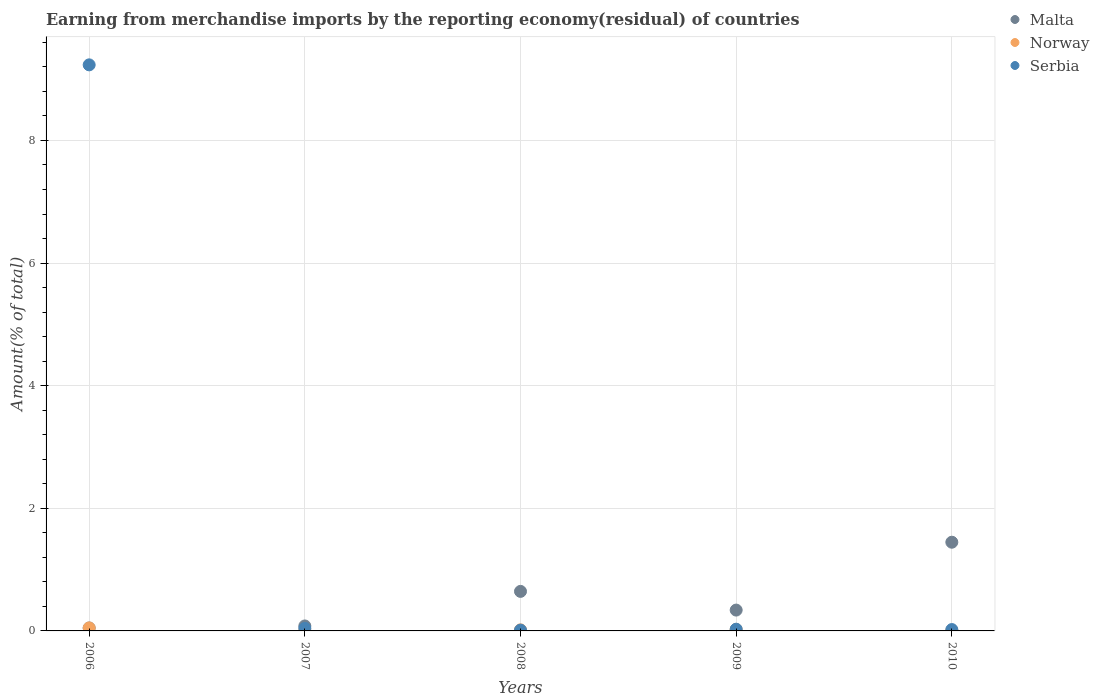Is the number of dotlines equal to the number of legend labels?
Your answer should be very brief. Yes. What is the percentage of amount earned from merchandise imports in Serbia in 2007?
Offer a very short reply. 0.04. Across all years, what is the maximum percentage of amount earned from merchandise imports in Malta?
Offer a very short reply. 1.45. Across all years, what is the minimum percentage of amount earned from merchandise imports in Norway?
Offer a terse response. 0.01. In which year was the percentage of amount earned from merchandise imports in Norway maximum?
Provide a short and direct response. 2006. What is the total percentage of amount earned from merchandise imports in Serbia in the graph?
Provide a short and direct response. 9.34. What is the difference between the percentage of amount earned from merchandise imports in Serbia in 2007 and that in 2010?
Your answer should be compact. 0.02. What is the difference between the percentage of amount earned from merchandise imports in Serbia in 2006 and the percentage of amount earned from merchandise imports in Norway in 2009?
Your answer should be compact. 9.21. What is the average percentage of amount earned from merchandise imports in Norway per year?
Provide a succinct answer. 0.02. In the year 2010, what is the difference between the percentage of amount earned from merchandise imports in Norway and percentage of amount earned from merchandise imports in Serbia?
Give a very brief answer. -0.01. In how many years, is the percentage of amount earned from merchandise imports in Malta greater than 4.4 %?
Offer a terse response. 0. What is the ratio of the percentage of amount earned from merchandise imports in Norway in 2006 to that in 2009?
Provide a short and direct response. 1.99. Is the percentage of amount earned from merchandise imports in Malta in 2007 less than that in 2009?
Your answer should be compact. Yes. What is the difference between the highest and the second highest percentage of amount earned from merchandise imports in Norway?
Your response must be concise. 0.02. What is the difference between the highest and the lowest percentage of amount earned from merchandise imports in Norway?
Provide a succinct answer. 0.04. Is it the case that in every year, the sum of the percentage of amount earned from merchandise imports in Serbia and percentage of amount earned from merchandise imports in Norway  is greater than the percentage of amount earned from merchandise imports in Malta?
Provide a succinct answer. No. Does the percentage of amount earned from merchandise imports in Malta monotonically increase over the years?
Your response must be concise. No. Is the percentage of amount earned from merchandise imports in Serbia strictly greater than the percentage of amount earned from merchandise imports in Norway over the years?
Your answer should be very brief. No. What is the difference between two consecutive major ticks on the Y-axis?
Provide a short and direct response. 2. Are the values on the major ticks of Y-axis written in scientific E-notation?
Offer a very short reply. No. Does the graph contain any zero values?
Offer a very short reply. No. Where does the legend appear in the graph?
Offer a very short reply. Top right. How many legend labels are there?
Provide a succinct answer. 3. How are the legend labels stacked?
Offer a terse response. Vertical. What is the title of the graph?
Offer a terse response. Earning from merchandise imports by the reporting economy(residual) of countries. What is the label or title of the Y-axis?
Keep it short and to the point. Amount(% of total). What is the Amount(% of total) in Malta in 2006?
Offer a terse response. 0.05. What is the Amount(% of total) of Norway in 2006?
Ensure brevity in your answer.  0.05. What is the Amount(% of total) of Serbia in 2006?
Provide a short and direct response. 9.23. What is the Amount(% of total) of Malta in 2007?
Provide a succinct answer. 0.08. What is the Amount(% of total) in Norway in 2007?
Offer a very short reply. 0.01. What is the Amount(% of total) in Serbia in 2007?
Your response must be concise. 0.04. What is the Amount(% of total) of Malta in 2008?
Give a very brief answer. 0.64. What is the Amount(% of total) of Norway in 2008?
Make the answer very short. 0.02. What is the Amount(% of total) of Serbia in 2008?
Your response must be concise. 0.01. What is the Amount(% of total) in Malta in 2009?
Your answer should be very brief. 0.34. What is the Amount(% of total) of Norway in 2009?
Ensure brevity in your answer.  0.02. What is the Amount(% of total) in Serbia in 2009?
Offer a very short reply. 0.03. What is the Amount(% of total) of Malta in 2010?
Keep it short and to the point. 1.45. What is the Amount(% of total) of Norway in 2010?
Provide a succinct answer. 0.01. What is the Amount(% of total) of Serbia in 2010?
Keep it short and to the point. 0.02. Across all years, what is the maximum Amount(% of total) of Malta?
Offer a very short reply. 1.45. Across all years, what is the maximum Amount(% of total) in Norway?
Provide a short and direct response. 0.05. Across all years, what is the maximum Amount(% of total) of Serbia?
Offer a terse response. 9.23. Across all years, what is the minimum Amount(% of total) of Malta?
Offer a terse response. 0.05. Across all years, what is the minimum Amount(% of total) in Norway?
Provide a short and direct response. 0.01. Across all years, what is the minimum Amount(% of total) in Serbia?
Your answer should be very brief. 0.01. What is the total Amount(% of total) of Malta in the graph?
Offer a very short reply. 2.56. What is the total Amount(% of total) of Norway in the graph?
Offer a terse response. 0.11. What is the total Amount(% of total) in Serbia in the graph?
Give a very brief answer. 9.34. What is the difference between the Amount(% of total) in Malta in 2006 and that in 2007?
Keep it short and to the point. -0.03. What is the difference between the Amount(% of total) in Norway in 2006 and that in 2007?
Provide a short and direct response. 0.04. What is the difference between the Amount(% of total) in Serbia in 2006 and that in 2007?
Offer a terse response. 9.19. What is the difference between the Amount(% of total) of Malta in 2006 and that in 2008?
Provide a short and direct response. -0.6. What is the difference between the Amount(% of total) in Norway in 2006 and that in 2008?
Ensure brevity in your answer.  0.03. What is the difference between the Amount(% of total) in Serbia in 2006 and that in 2008?
Provide a short and direct response. 9.22. What is the difference between the Amount(% of total) in Malta in 2006 and that in 2009?
Offer a terse response. -0.29. What is the difference between the Amount(% of total) in Norway in 2006 and that in 2009?
Your answer should be compact. 0.02. What is the difference between the Amount(% of total) in Serbia in 2006 and that in 2009?
Keep it short and to the point. 9.21. What is the difference between the Amount(% of total) of Malta in 2006 and that in 2010?
Provide a succinct answer. -1.4. What is the difference between the Amount(% of total) in Norway in 2006 and that in 2010?
Offer a terse response. 0.04. What is the difference between the Amount(% of total) in Serbia in 2006 and that in 2010?
Offer a very short reply. 9.21. What is the difference between the Amount(% of total) of Malta in 2007 and that in 2008?
Offer a terse response. -0.56. What is the difference between the Amount(% of total) in Norway in 2007 and that in 2008?
Offer a very short reply. -0.01. What is the difference between the Amount(% of total) in Serbia in 2007 and that in 2008?
Ensure brevity in your answer.  0.03. What is the difference between the Amount(% of total) in Malta in 2007 and that in 2009?
Ensure brevity in your answer.  -0.26. What is the difference between the Amount(% of total) of Norway in 2007 and that in 2009?
Provide a succinct answer. -0.02. What is the difference between the Amount(% of total) of Serbia in 2007 and that in 2009?
Provide a succinct answer. 0.01. What is the difference between the Amount(% of total) of Malta in 2007 and that in 2010?
Your response must be concise. -1.37. What is the difference between the Amount(% of total) in Norway in 2007 and that in 2010?
Give a very brief answer. -0. What is the difference between the Amount(% of total) in Serbia in 2007 and that in 2010?
Offer a terse response. 0.02. What is the difference between the Amount(% of total) of Malta in 2008 and that in 2009?
Provide a short and direct response. 0.3. What is the difference between the Amount(% of total) in Norway in 2008 and that in 2009?
Your answer should be very brief. -0.01. What is the difference between the Amount(% of total) in Serbia in 2008 and that in 2009?
Keep it short and to the point. -0.01. What is the difference between the Amount(% of total) in Malta in 2008 and that in 2010?
Your answer should be compact. -0.8. What is the difference between the Amount(% of total) in Norway in 2008 and that in 2010?
Keep it short and to the point. 0.01. What is the difference between the Amount(% of total) of Serbia in 2008 and that in 2010?
Your answer should be very brief. -0.01. What is the difference between the Amount(% of total) in Malta in 2009 and that in 2010?
Offer a very short reply. -1.11. What is the difference between the Amount(% of total) of Norway in 2009 and that in 2010?
Provide a short and direct response. 0.01. What is the difference between the Amount(% of total) in Serbia in 2009 and that in 2010?
Your response must be concise. 0.01. What is the difference between the Amount(% of total) of Malta in 2006 and the Amount(% of total) of Norway in 2007?
Provide a succinct answer. 0.04. What is the difference between the Amount(% of total) of Malta in 2006 and the Amount(% of total) of Serbia in 2007?
Ensure brevity in your answer.  0.01. What is the difference between the Amount(% of total) of Norway in 2006 and the Amount(% of total) of Serbia in 2007?
Offer a very short reply. 0.01. What is the difference between the Amount(% of total) of Malta in 2006 and the Amount(% of total) of Norway in 2008?
Your answer should be very brief. 0.03. What is the difference between the Amount(% of total) in Malta in 2006 and the Amount(% of total) in Serbia in 2008?
Make the answer very short. 0.03. What is the difference between the Amount(% of total) of Norway in 2006 and the Amount(% of total) of Serbia in 2008?
Give a very brief answer. 0.04. What is the difference between the Amount(% of total) of Malta in 2006 and the Amount(% of total) of Norway in 2009?
Your response must be concise. 0.02. What is the difference between the Amount(% of total) in Malta in 2006 and the Amount(% of total) in Serbia in 2009?
Provide a succinct answer. 0.02. What is the difference between the Amount(% of total) in Norway in 2006 and the Amount(% of total) in Serbia in 2009?
Offer a terse response. 0.02. What is the difference between the Amount(% of total) of Malta in 2006 and the Amount(% of total) of Norway in 2010?
Make the answer very short. 0.04. What is the difference between the Amount(% of total) in Malta in 2006 and the Amount(% of total) in Serbia in 2010?
Give a very brief answer. 0.03. What is the difference between the Amount(% of total) of Norway in 2006 and the Amount(% of total) of Serbia in 2010?
Offer a very short reply. 0.03. What is the difference between the Amount(% of total) in Malta in 2007 and the Amount(% of total) in Norway in 2008?
Provide a succinct answer. 0.06. What is the difference between the Amount(% of total) in Malta in 2007 and the Amount(% of total) in Serbia in 2008?
Your answer should be compact. 0.07. What is the difference between the Amount(% of total) of Norway in 2007 and the Amount(% of total) of Serbia in 2008?
Make the answer very short. -0.01. What is the difference between the Amount(% of total) in Malta in 2007 and the Amount(% of total) in Norway in 2009?
Provide a succinct answer. 0.06. What is the difference between the Amount(% of total) in Malta in 2007 and the Amount(% of total) in Serbia in 2009?
Give a very brief answer. 0.05. What is the difference between the Amount(% of total) of Norway in 2007 and the Amount(% of total) of Serbia in 2009?
Make the answer very short. -0.02. What is the difference between the Amount(% of total) in Malta in 2007 and the Amount(% of total) in Norway in 2010?
Offer a terse response. 0.07. What is the difference between the Amount(% of total) of Malta in 2007 and the Amount(% of total) of Serbia in 2010?
Provide a short and direct response. 0.06. What is the difference between the Amount(% of total) in Norway in 2007 and the Amount(% of total) in Serbia in 2010?
Make the answer very short. -0.01. What is the difference between the Amount(% of total) of Malta in 2008 and the Amount(% of total) of Norway in 2009?
Your answer should be compact. 0.62. What is the difference between the Amount(% of total) of Malta in 2008 and the Amount(% of total) of Serbia in 2009?
Ensure brevity in your answer.  0.62. What is the difference between the Amount(% of total) of Norway in 2008 and the Amount(% of total) of Serbia in 2009?
Offer a terse response. -0.01. What is the difference between the Amount(% of total) in Malta in 2008 and the Amount(% of total) in Norway in 2010?
Provide a succinct answer. 0.64. What is the difference between the Amount(% of total) of Malta in 2008 and the Amount(% of total) of Serbia in 2010?
Your answer should be compact. 0.62. What is the difference between the Amount(% of total) of Norway in 2008 and the Amount(% of total) of Serbia in 2010?
Your answer should be very brief. -0.01. What is the difference between the Amount(% of total) of Malta in 2009 and the Amount(% of total) of Norway in 2010?
Your answer should be very brief. 0.33. What is the difference between the Amount(% of total) of Malta in 2009 and the Amount(% of total) of Serbia in 2010?
Provide a succinct answer. 0.32. What is the difference between the Amount(% of total) of Norway in 2009 and the Amount(% of total) of Serbia in 2010?
Offer a terse response. 0. What is the average Amount(% of total) of Malta per year?
Offer a terse response. 0.51. What is the average Amount(% of total) in Norway per year?
Offer a terse response. 0.02. What is the average Amount(% of total) in Serbia per year?
Your answer should be compact. 1.87. In the year 2006, what is the difference between the Amount(% of total) of Malta and Amount(% of total) of Norway?
Your answer should be very brief. -0. In the year 2006, what is the difference between the Amount(% of total) in Malta and Amount(% of total) in Serbia?
Ensure brevity in your answer.  -9.19. In the year 2006, what is the difference between the Amount(% of total) of Norway and Amount(% of total) of Serbia?
Your answer should be compact. -9.18. In the year 2007, what is the difference between the Amount(% of total) in Malta and Amount(% of total) in Norway?
Make the answer very short. 0.07. In the year 2007, what is the difference between the Amount(% of total) of Malta and Amount(% of total) of Serbia?
Offer a very short reply. 0.04. In the year 2007, what is the difference between the Amount(% of total) of Norway and Amount(% of total) of Serbia?
Provide a succinct answer. -0.03. In the year 2008, what is the difference between the Amount(% of total) in Malta and Amount(% of total) in Norway?
Your answer should be compact. 0.63. In the year 2008, what is the difference between the Amount(% of total) in Malta and Amount(% of total) in Serbia?
Your response must be concise. 0.63. In the year 2008, what is the difference between the Amount(% of total) of Norway and Amount(% of total) of Serbia?
Give a very brief answer. 0. In the year 2009, what is the difference between the Amount(% of total) of Malta and Amount(% of total) of Norway?
Make the answer very short. 0.32. In the year 2009, what is the difference between the Amount(% of total) of Malta and Amount(% of total) of Serbia?
Provide a succinct answer. 0.31. In the year 2009, what is the difference between the Amount(% of total) of Norway and Amount(% of total) of Serbia?
Give a very brief answer. -0. In the year 2010, what is the difference between the Amount(% of total) of Malta and Amount(% of total) of Norway?
Provide a succinct answer. 1.44. In the year 2010, what is the difference between the Amount(% of total) in Malta and Amount(% of total) in Serbia?
Provide a succinct answer. 1.42. In the year 2010, what is the difference between the Amount(% of total) in Norway and Amount(% of total) in Serbia?
Provide a succinct answer. -0.01. What is the ratio of the Amount(% of total) of Malta in 2006 to that in 2007?
Offer a very short reply. 0.59. What is the ratio of the Amount(% of total) in Norway in 2006 to that in 2007?
Provide a short and direct response. 6.37. What is the ratio of the Amount(% of total) of Serbia in 2006 to that in 2007?
Keep it short and to the point. 222.25. What is the ratio of the Amount(% of total) in Malta in 2006 to that in 2008?
Offer a terse response. 0.07. What is the ratio of the Amount(% of total) of Norway in 2006 to that in 2008?
Keep it short and to the point. 2.82. What is the ratio of the Amount(% of total) in Serbia in 2006 to that in 2008?
Keep it short and to the point. 708.68. What is the ratio of the Amount(% of total) of Malta in 2006 to that in 2009?
Ensure brevity in your answer.  0.14. What is the ratio of the Amount(% of total) in Norway in 2006 to that in 2009?
Make the answer very short. 1.99. What is the ratio of the Amount(% of total) of Serbia in 2006 to that in 2009?
Your response must be concise. 329.11. What is the ratio of the Amount(% of total) in Malta in 2006 to that in 2010?
Your response must be concise. 0.03. What is the ratio of the Amount(% of total) of Norway in 2006 to that in 2010?
Offer a terse response. 5.1. What is the ratio of the Amount(% of total) of Serbia in 2006 to that in 2010?
Your answer should be very brief. 414.45. What is the ratio of the Amount(% of total) in Malta in 2007 to that in 2008?
Keep it short and to the point. 0.13. What is the ratio of the Amount(% of total) of Norway in 2007 to that in 2008?
Provide a short and direct response. 0.44. What is the ratio of the Amount(% of total) of Serbia in 2007 to that in 2008?
Provide a succinct answer. 3.19. What is the ratio of the Amount(% of total) of Malta in 2007 to that in 2009?
Make the answer very short. 0.24. What is the ratio of the Amount(% of total) of Norway in 2007 to that in 2009?
Give a very brief answer. 0.31. What is the ratio of the Amount(% of total) in Serbia in 2007 to that in 2009?
Keep it short and to the point. 1.48. What is the ratio of the Amount(% of total) of Malta in 2007 to that in 2010?
Make the answer very short. 0.06. What is the ratio of the Amount(% of total) in Norway in 2007 to that in 2010?
Ensure brevity in your answer.  0.8. What is the ratio of the Amount(% of total) of Serbia in 2007 to that in 2010?
Your answer should be compact. 1.86. What is the ratio of the Amount(% of total) in Malta in 2008 to that in 2009?
Your answer should be compact. 1.9. What is the ratio of the Amount(% of total) in Norway in 2008 to that in 2009?
Provide a short and direct response. 0.7. What is the ratio of the Amount(% of total) of Serbia in 2008 to that in 2009?
Provide a short and direct response. 0.46. What is the ratio of the Amount(% of total) in Malta in 2008 to that in 2010?
Keep it short and to the point. 0.45. What is the ratio of the Amount(% of total) in Norway in 2008 to that in 2010?
Offer a very short reply. 1.81. What is the ratio of the Amount(% of total) in Serbia in 2008 to that in 2010?
Provide a short and direct response. 0.58. What is the ratio of the Amount(% of total) in Malta in 2009 to that in 2010?
Keep it short and to the point. 0.23. What is the ratio of the Amount(% of total) of Norway in 2009 to that in 2010?
Offer a terse response. 2.57. What is the ratio of the Amount(% of total) in Serbia in 2009 to that in 2010?
Your answer should be compact. 1.26. What is the difference between the highest and the second highest Amount(% of total) in Malta?
Provide a short and direct response. 0.8. What is the difference between the highest and the second highest Amount(% of total) of Norway?
Provide a succinct answer. 0.02. What is the difference between the highest and the second highest Amount(% of total) in Serbia?
Keep it short and to the point. 9.19. What is the difference between the highest and the lowest Amount(% of total) in Malta?
Ensure brevity in your answer.  1.4. What is the difference between the highest and the lowest Amount(% of total) of Norway?
Give a very brief answer. 0.04. What is the difference between the highest and the lowest Amount(% of total) in Serbia?
Your answer should be very brief. 9.22. 